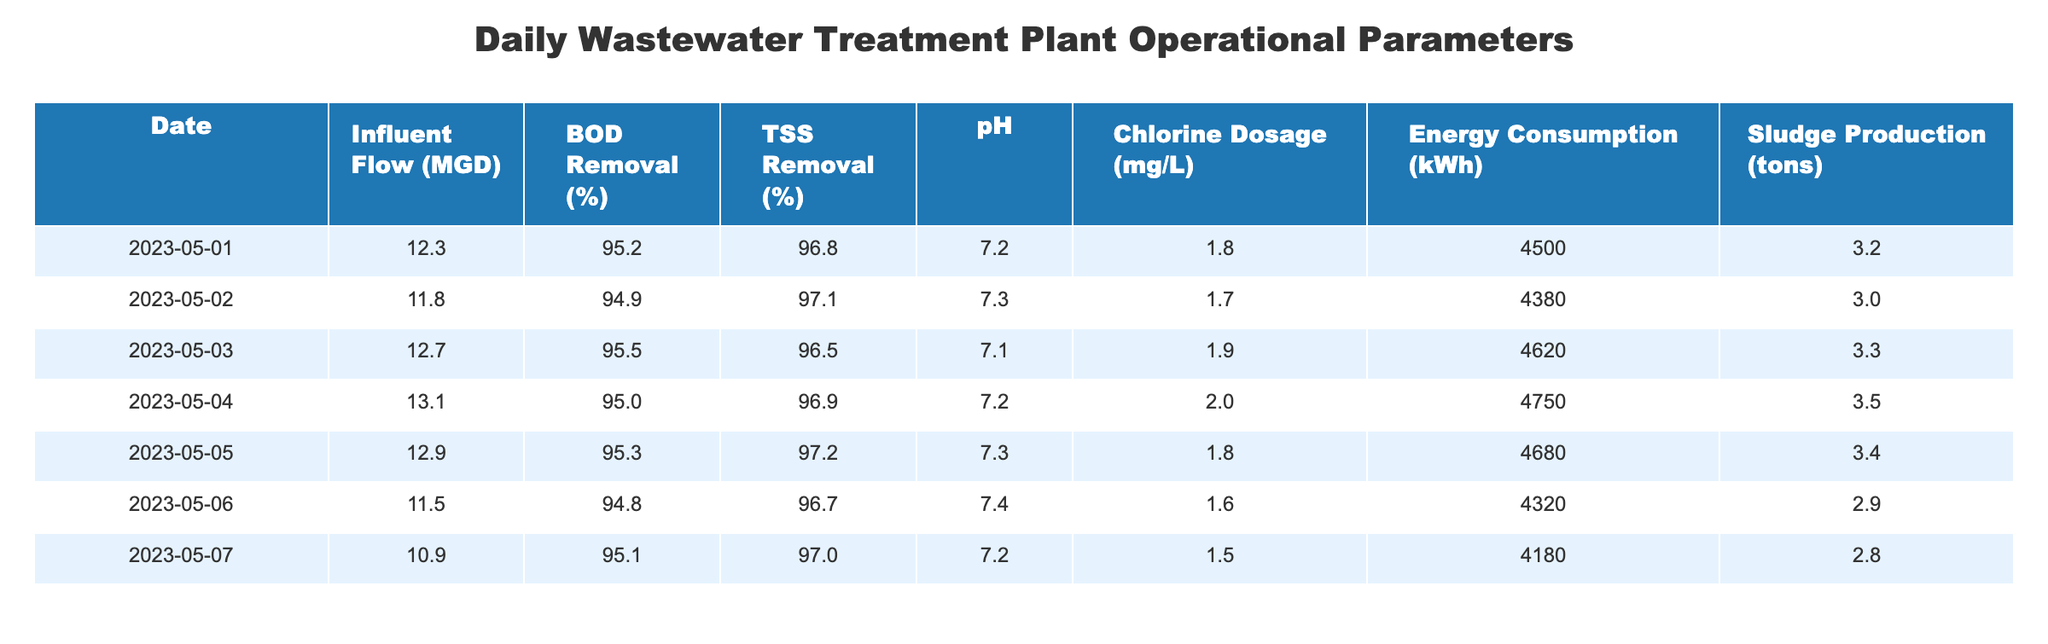What was the influent flow on May 03, 2023? The influent flow value for May 03, 2023, is listed in the table. By referring to the row corresponding to that date, the influent flow amount is 12.7 MGD.
Answer: 12.7 MGD What is the highest BOD removal percentage recorded in the table? By scanning through the BOD removal percentages across all dates in the table, the highest value is 95.5% on May 03, 2023.
Answer: 95.5% Calculate the average TSS removal percentage for the recorded days. The TSS removal percentages are 96.8, 97.1, 96.5, 96.9, 97.2, 96.7, and 97.0. To find the average, add these values: (96.8 + 97.1 + 96.5 + 96.9 + 97.2 + 96.7 + 97.0) = 680.2. Then divide by the number of days (7), yielding an average of 680.2 / 7 ≈ 97.2.
Answer: 97.2 Was the energy consumption on May 06 less than on May 05? On May 06, the energy consumption was 4320 kWh, and on May 05, it was 4680 kWh. Since 4320 is indeed less than 4680, the answer is yes.
Answer: Yes How much chlorine was dosed on the day with the lowest influent flow? The lowest influent flow listed is 10.9 MGD on May 07, 2023. The chlorine dosage for that date is 1.5 mg/L, which can be found in the corresponding row of the table.
Answer: 1.5 mg/L What was the sludge production on the day with the highest energy consumption? By reviewing the energy consumption for each date, the highest figure is 4750 kWh on May 04, 2023. The sludge production for that day is found in the same row, which is 3.5 tons.
Answer: 3.5 tons Calculate the total influent flow over the recorded days. The influent flow values are 12.3, 11.8, 12.7, 13.1, 12.9, 11.5, and 10.9. Summing these gives: 12.3 + 11.8 + 12.7 + 13.1 + 12.9 + 11.5 + 10.9 =  91.2 MGD.
Answer: 91.2 MGD Was the pH value ever lower than 7.0 during the recorded days? The pH values listed are 7.2, 7.3, 7.1, 7.2, 7.3, 7.4, and 7.2. All of these values are higher than 7.0, thus the answer is no.
Answer: No 